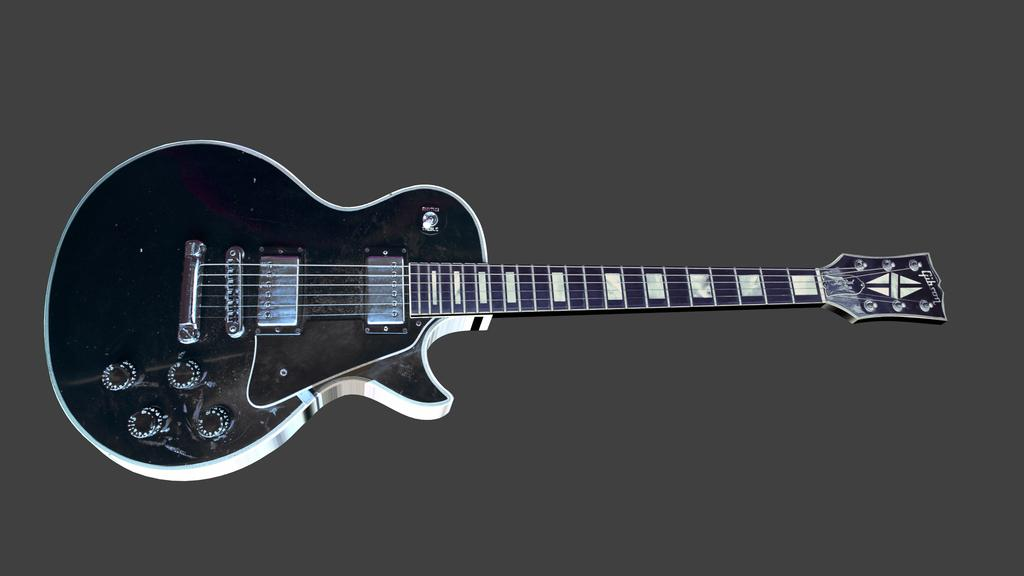What musical instrument is present in the image? There is a guitar in the picture. What color scheme is used for the guitar? The guitar is in black and white color. What color is the background of the image? The background of the image is grey in color. Can you tell if the image has been edited or altered in any way? The image might be edited, as it is not explicitly stated that it is an unaltered photograph. What type of selection is being made by the coach in the image? There is no coach or selection process depicted in the image; it only features a guitar. Can you tell me what flavor of cracker is being held by the person in the image? There is no person or cracker present in the image; it only features a guitar. 